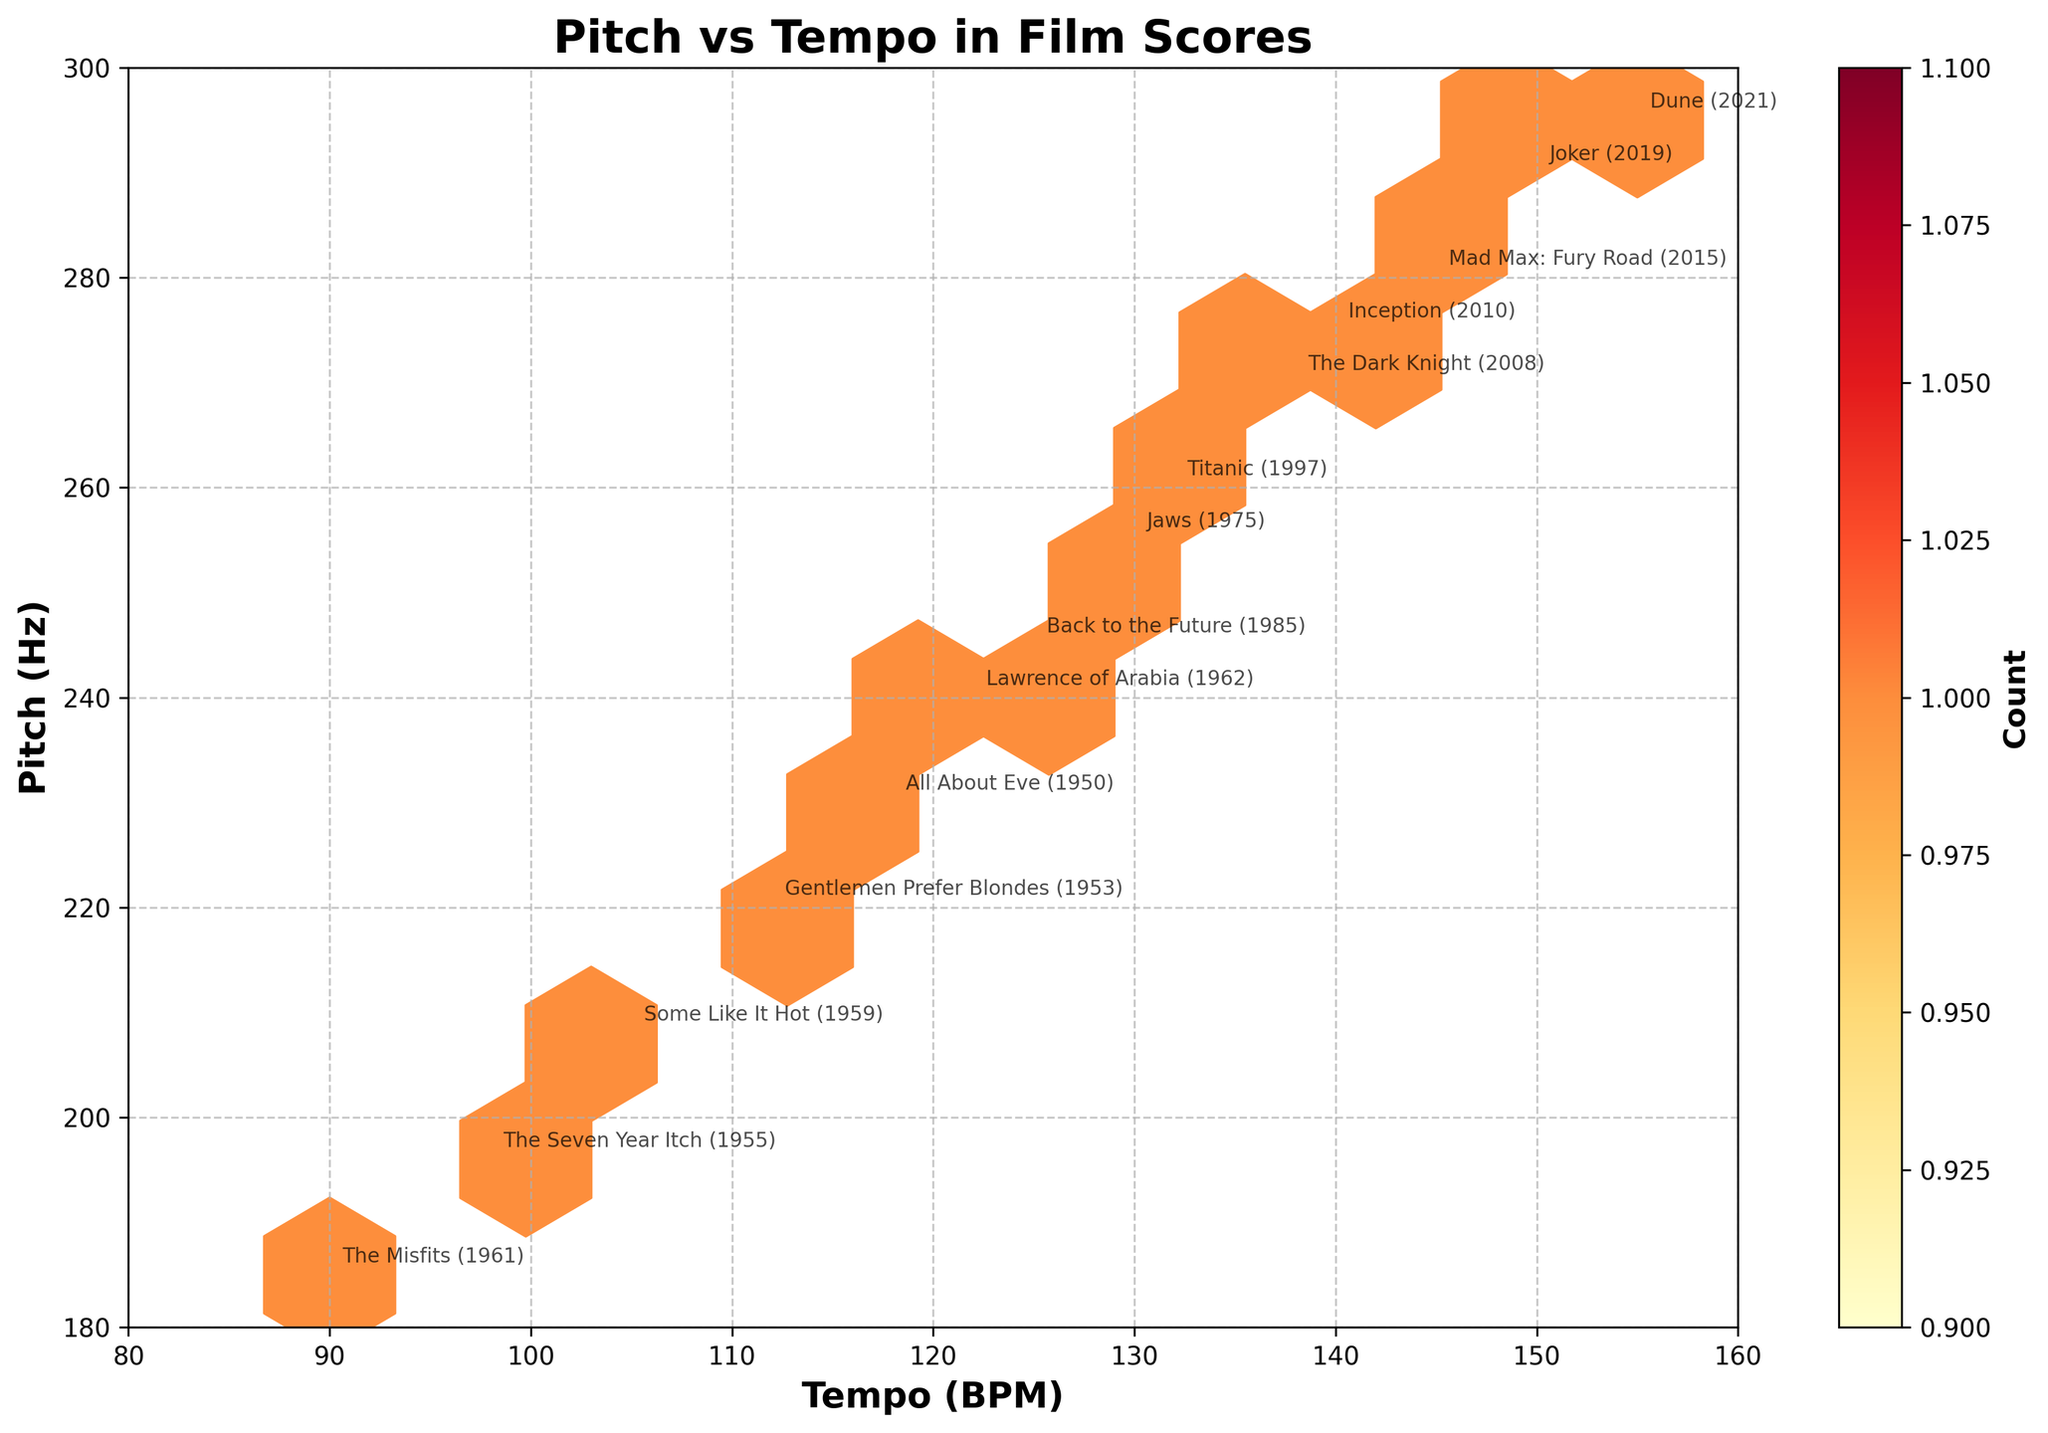What is the title of the figure? The title of the figure is usually displayed at the top. Here, it reads "Pitch vs Tempo in Film Scores" as visible in a large, bold font.
Answer: Pitch vs Tempo in Film Scores What is the range of the x-axis? The x-axis represents Tempo (BPM) and we can observe its range by looking at the axis ticks. It starts at 80 and ends at 160.
Answer: 80 to 160 Which data point has the highest tempo? The data point with the highest tempo is "Dune (2021)" with a tempo value of 155 BPM. This can be found by looking at the labels on the plot.
Answer: Dune (2021) What is the color of the hexagons representing the least populated areas? The least populated areas in a hexbin plot are generally represented by the lightest color in the color map used. Here, the lightest hexagons are colored yellow.
Answer: Yellow How many data points represent movies from Marilyn Monroe's era (1950s-1960s)? To find the number of data points from Marilyn Monroe's era, count the data points labeled with the years 1950 to 1962. There are five such data points.
Answer: 5 Which movie has the highest pitch value? The movie "Dune (2021)" has the highest pitch value. The pitch is 295 Hz, which can be found on the y-axis.
Answer: Dune (2021) How does the average pitch of films from the 1950s-1960s compare to those of modern cinema? Calculate the average pitches for the two periods. Films from 1950s-1960s: (220 + 196 + 208 + 185 + 230 + 240) / 6 = 213.17 Hz; Modern cinema (post-1980): (245 + 260 + 275 + 290 + 255 + 270 + 280 + 295) / 8 = 271.25 Hz.
Answer: Modern cinema has a higher average pitch Which movie has both tempo and pitch close to the median values of all tempos and pitches? To find the median values: Median tempo = 125 BPM, Median pitch = 255 Hz. "Jaws (1975)" is the data point with both values close to the medians.
Answer: Jaws (1975) Do modern films tend to have higher tempos than films from Marilyn Monroe's era? By comparing the range of tempo values from each period: Marilyn Monroe's era shows tempos ranging from 90 to 122 BPM, while modern films range from 125 to 155 BPM. Modern films tend to have higher tempos.
Answer: Yes Is there a general trend between tempo and pitch across the dataset? By observing the overall shape in the hexbin plot, there seems to be a tendency where higher tempos correlate with higher pitches, suggesting a positive trend.
Answer: Yes 